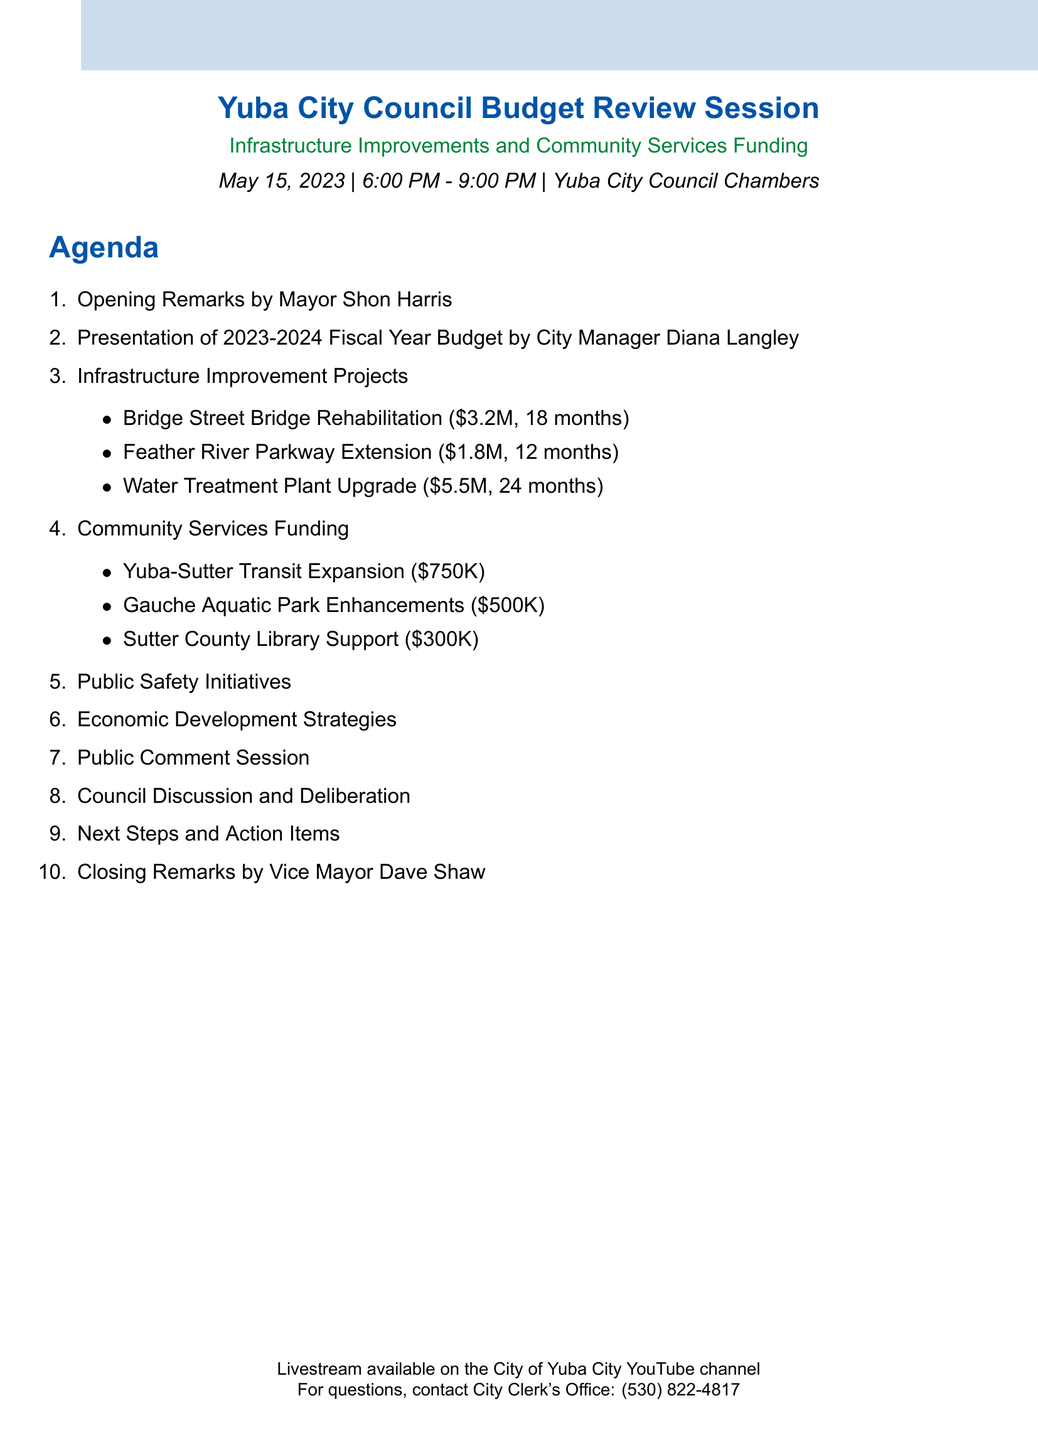What is the date of the budget review session? The date is specified in the document as May 15, 2023.
Answer: May 15, 2023 Who presents the overview of the proposed budget? The document states that City Manager Diana Langley presents the budget.
Answer: Diana Langley What is the estimated cost of the Water Treatment Plant Upgrade? The document lists the estimated cost as $5.5 million.
Answer: $5.5 million How long is the timeline for the Bridge Street Bridge Rehabilitation project? The timeline for this project is indicated as 18 months in the document.
Answer: 18 months What is the proposed budget for the Sutter County Library Support? The proposed budget for this program is $300,000 as mentioned in the agenda.
Answer: $300,000 What improvements are planned for Gauche Aquatic Park? The document outlines improvements as new water slides and accessibility features.
Answer: New water slides and accessibility features What is the main focus during the Council Discussion and Deliberation? Key points include prioritization of projects and funding sources as mentioned in the document.
Answer: Prioritization of projects Where is the budget review session held? The venue of the session is explicitly stated as Yuba City Council Chambers.
Answer: Yuba City Council Chambers What is available for residents during the Public Comment Session? The document details that residents can voice their opinions on the proposed budget allocations.
Answer: Voice their opinions on the proposed budget allocations 